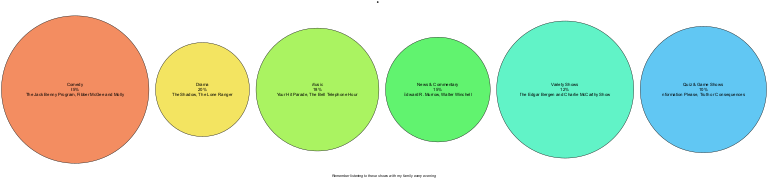What is the genre with the highest percentage in the pie chart? The pie chart shows the distribution of various radio programming genres. By examining the percentages, we see that the largest slice is allocated to Comedy, which has a percentage of 25.
Answer: Comedy How much percentage of the pie chart is dedicated to Music? By looking at the pie chart, we can find the slice labeled Music, which shows a percentage of 18. This means that 18% of the programming was devoted to this genre.
Answer: 18 What two genres combined make up 45% of the pie chart? From the chart, we see that Comedy accounts for 25% and Drama accounts for 20%. By adding these percentages together (25 + 20), we find that these two genres combined account for 45% of the total.
Answer: 45% Which genre features examples like "The Shadow" and "The Lone Ranger"? Looking at the genres listed, we identify that Drama is the genre associated with those examples. The pie chart specifically shows Drama, along with its examples, matching the query.
Answer: Drama What percentage of the programming was dedicated to Quiz & Game Shows? Upon reviewing the pie chart, we see that Quiz & Game Shows have been assigned a percentage of 10. This information is explicitly shown in the slice for that genre.
Answer: 10 How many genres are included in the pie chart? By counting the specific genres presented in the pie chart, we find there are six distinct genres listed: Comedy, Drama, Music, News & Commentary, Variety Shows, and Quiz & Game Shows. Therefore, the total number is 6.
Answer: 6 Which genre has the smallest portion of the pie? The pie chart indicates that Quiz & Game Shows have the smallest percentage, which is recorded at 10. Hence, this genre occupies the least space in the chart.
Answer: Quiz & Game Shows Name one program example from the Variety Shows genre. By referencing the pie chart, we see that The Edgar Bergen and Charlie McCarthy Show is specifically listed as an example of the Variety Shows genre. Thus, this is one program associated with it.
Answer: The Edgar Bergen and Charlie McCarthy Show 